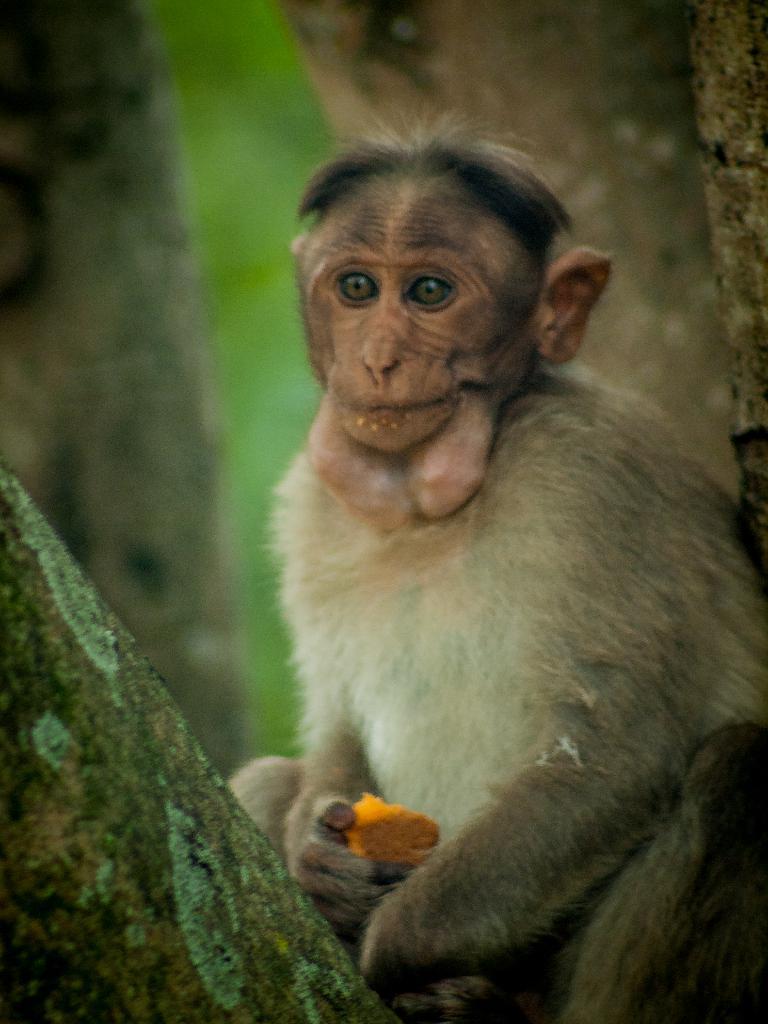Describe this image in one or two sentences. In this image there is a monkey sitting and holding an object, there are tree trunks, the background of the image is blurred. 